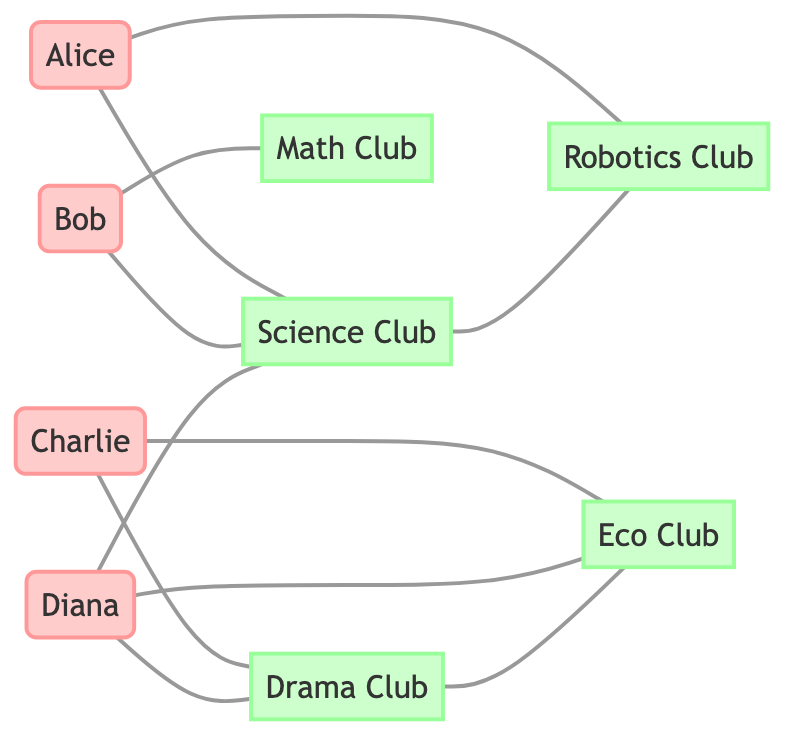What is the total number of students in the diagram? The nodes represent the participants, labeled as students. There are four students (Alice, Bob, Charlie, and Diana) listed in the nodes section.
Answer: 4 Which club is Charlie a member of? To find Charlie's memberships, we look at the edges connected to Charlie. The edges indicate that Charlie is connected to the Drama Club and the Eco Club. Therefore, Charlie is a member of both clubs.
Answer: Drama Club, Eco Club How many edges connect members to clubs? Each edge represents a connection between a student and a club. By counting the edges related to the nodes representing students and clubs, we find there are a total of 10 edges.
Answer: 10 Which club connects with the most students? We analyze the students' connections to their clubs by counting the edges linked to each club. The Science Club has connections to Alice, Bob, and Diana, giving it a total of three student connections.
Answer: Science Club Does Diana belong to the Robotics Club? To answer this, we check the edges from Diana. The edges show that Diana connects only with the Science Club, Eco Club, and Drama Club, but not with the Robotics Club.
Answer: No How many clubs does Bob belong to? We review Bob's edges to determine his memberships. Bob has edges connecting him to the Science Club and the Math Club, showing he belongs to two clubs.
Answer: 2 Which students are connected to the Eco Club? We find all edges that connect to the Eco Club. The edges show that Diana and Charlie are connected to the Eco Club, indicating that these two students are members.
Answer: Diana, Charlie Is there a connection between the Robotics Club and the Eco Club? We look for edges connecting these two clubs. Since the diagram shows no direct edge between the Robotics Club and the Eco Club, they are not connected.
Answer: No Which two clubs have a direct connection to each other? By reviewing the edges in the diagram, we can find direct connections. Science Club has a direct connection to the Robotics Club, and the Drama Club has a direct connection to the Eco Club.
Answer: Science Club, Robotics Club; Drama Club, Eco Club 